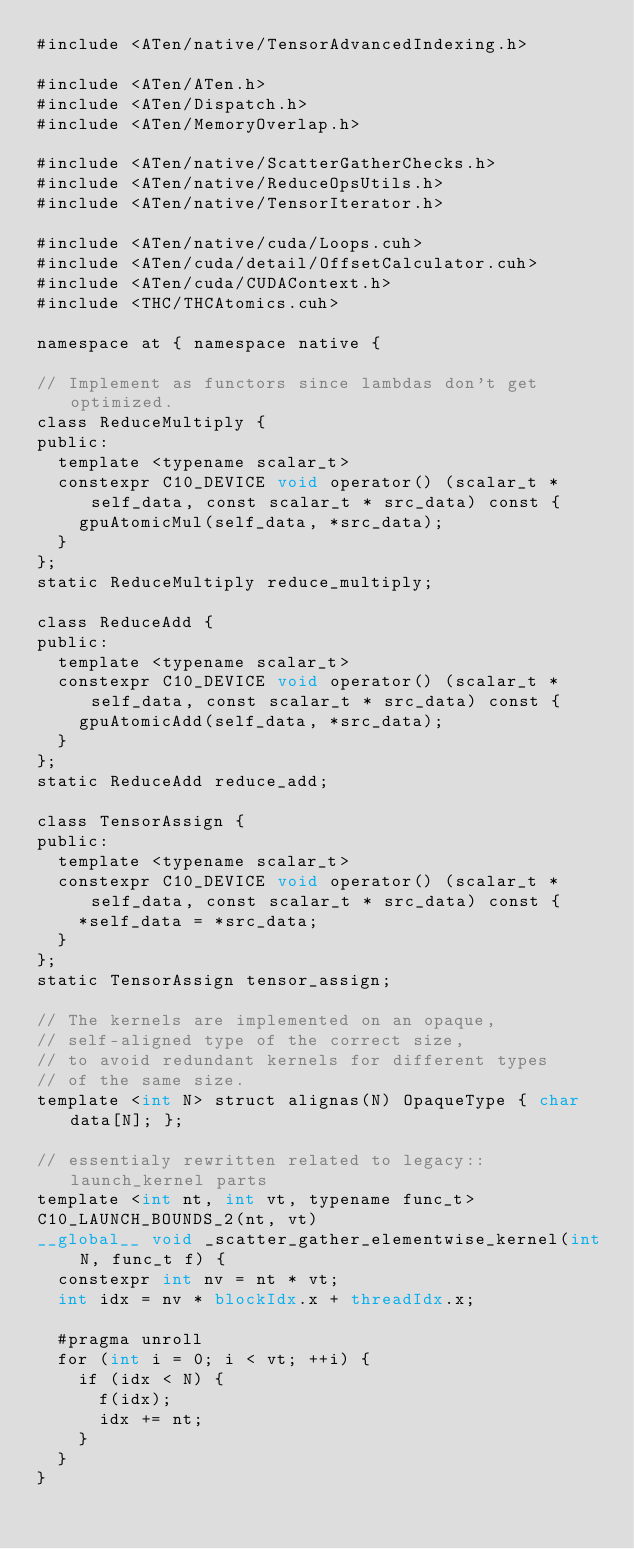<code> <loc_0><loc_0><loc_500><loc_500><_Cuda_>#include <ATen/native/TensorAdvancedIndexing.h>

#include <ATen/ATen.h>
#include <ATen/Dispatch.h>
#include <ATen/MemoryOverlap.h>

#include <ATen/native/ScatterGatherChecks.h>
#include <ATen/native/ReduceOpsUtils.h>
#include <ATen/native/TensorIterator.h>

#include <ATen/native/cuda/Loops.cuh>
#include <ATen/cuda/detail/OffsetCalculator.cuh>
#include <ATen/cuda/CUDAContext.h>
#include <THC/THCAtomics.cuh>

namespace at { namespace native {

// Implement as functors since lambdas don't get optimized.
class ReduceMultiply {
public:
  template <typename scalar_t>
  constexpr C10_DEVICE void operator() (scalar_t * self_data, const scalar_t * src_data) const {
    gpuAtomicMul(self_data, *src_data);
  }
};
static ReduceMultiply reduce_multiply;

class ReduceAdd {
public:
  template <typename scalar_t>
  constexpr C10_DEVICE void operator() (scalar_t * self_data, const scalar_t * src_data) const {
    gpuAtomicAdd(self_data, *src_data);
  }
};
static ReduceAdd reduce_add;

class TensorAssign {
public:
  template <typename scalar_t>
  constexpr C10_DEVICE void operator() (scalar_t * self_data, const scalar_t * src_data) const {
    *self_data = *src_data;
  }
};
static TensorAssign tensor_assign;

// The kernels are implemented on an opaque,
// self-aligned type of the correct size,
// to avoid redundant kernels for different types
// of the same size.
template <int N> struct alignas(N) OpaqueType { char data[N]; };

// essentialy rewritten related to legacy::launch_kernel parts
template <int nt, int vt, typename func_t>
C10_LAUNCH_BOUNDS_2(nt, vt)
__global__ void _scatter_gather_elementwise_kernel(int N, func_t f) {
  constexpr int nv = nt * vt;
  int idx = nv * blockIdx.x + threadIdx.x;

  #pragma unroll
  for (int i = 0; i < vt; ++i) {
    if (idx < N) {
      f(idx);
      idx += nt;
    }
  }
}
</code> 